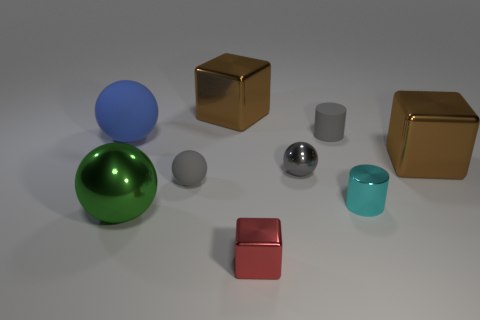Is there a pattern to the arrangement of the objects? The objects in the image appear to be arranged without a specific pattern. Their placement on the surface seems random, with varying distances between them, suggesting there are no strict rules governing their placement. However, one might observe a subtle gradient in size from the larger objects in the back row to the smaller ones in the front, potentially creating a sense of depth in the composition. 